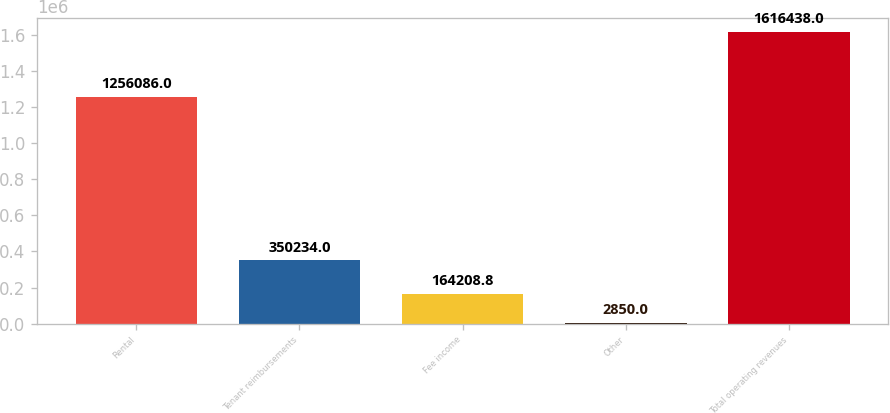Convert chart. <chart><loc_0><loc_0><loc_500><loc_500><bar_chart><fcel>Rental<fcel>Tenant reimbursements<fcel>Fee income<fcel>Other<fcel>Total operating revenues<nl><fcel>1.25609e+06<fcel>350234<fcel>164209<fcel>2850<fcel>1.61644e+06<nl></chart> 